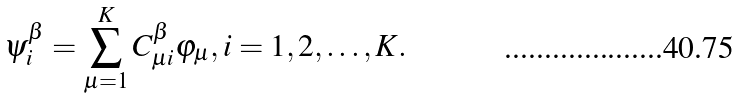Convert formula to latex. <formula><loc_0><loc_0><loc_500><loc_500>\psi ^ { \beta } _ { i } = \sum _ { \mu = 1 } ^ { K } C _ { \mu i } ^ { \beta } \varphi _ { \mu } , i = 1 , 2 , \dots , K .</formula> 